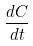Convert formula to latex. <formula><loc_0><loc_0><loc_500><loc_500>\frac { d C } { d t }</formula> 